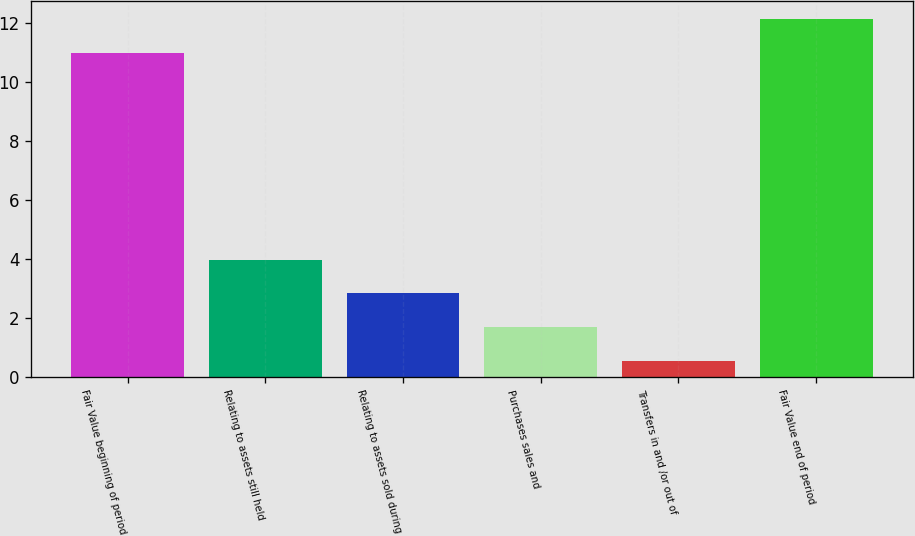Convert chart to OTSL. <chart><loc_0><loc_0><loc_500><loc_500><bar_chart><fcel>Fair Value beginning of period<fcel>Relating to assets still held<fcel>Relating to assets sold during<fcel>Purchases sales and<fcel>Transfers in and /or out of<fcel>Fair Value end of period<nl><fcel>11<fcel>3.99<fcel>2.84<fcel>1.69<fcel>0.54<fcel>12.15<nl></chart> 